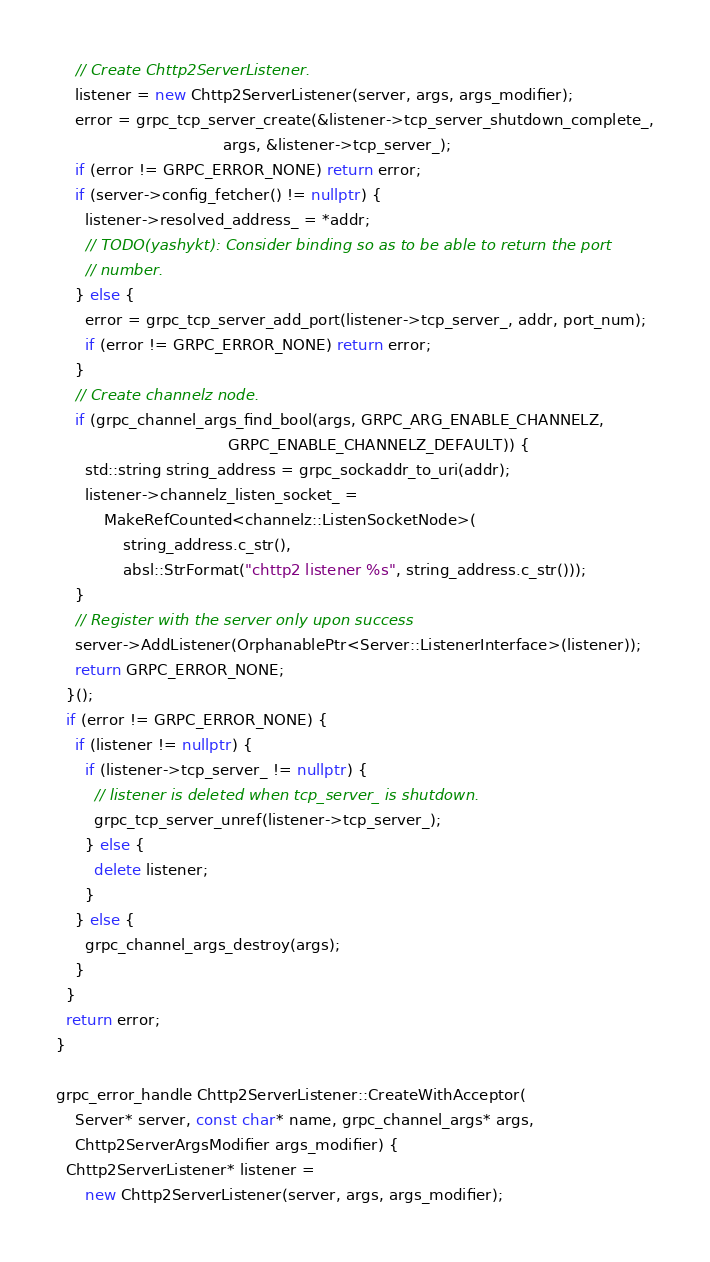Convert code to text. <code><loc_0><loc_0><loc_500><loc_500><_C++_>    // Create Chttp2ServerListener.
    listener = new Chttp2ServerListener(server, args, args_modifier);
    error = grpc_tcp_server_create(&listener->tcp_server_shutdown_complete_,
                                   args, &listener->tcp_server_);
    if (error != GRPC_ERROR_NONE) return error;
    if (server->config_fetcher() != nullptr) {
      listener->resolved_address_ = *addr;
      // TODO(yashykt): Consider binding so as to be able to return the port
      // number.
    } else {
      error = grpc_tcp_server_add_port(listener->tcp_server_, addr, port_num);
      if (error != GRPC_ERROR_NONE) return error;
    }
    // Create channelz node.
    if (grpc_channel_args_find_bool(args, GRPC_ARG_ENABLE_CHANNELZ,
                                    GRPC_ENABLE_CHANNELZ_DEFAULT)) {
      std::string string_address = grpc_sockaddr_to_uri(addr);
      listener->channelz_listen_socket_ =
          MakeRefCounted<channelz::ListenSocketNode>(
              string_address.c_str(),
              absl::StrFormat("chttp2 listener %s", string_address.c_str()));
    }
    // Register with the server only upon success
    server->AddListener(OrphanablePtr<Server::ListenerInterface>(listener));
    return GRPC_ERROR_NONE;
  }();
  if (error != GRPC_ERROR_NONE) {
    if (listener != nullptr) {
      if (listener->tcp_server_ != nullptr) {
        // listener is deleted when tcp_server_ is shutdown.
        grpc_tcp_server_unref(listener->tcp_server_);
      } else {
        delete listener;
      }
    } else {
      grpc_channel_args_destroy(args);
    }
  }
  return error;
}

grpc_error_handle Chttp2ServerListener::CreateWithAcceptor(
    Server* server, const char* name, grpc_channel_args* args,
    Chttp2ServerArgsModifier args_modifier) {
  Chttp2ServerListener* listener =
      new Chttp2ServerListener(server, args, args_modifier);</code> 